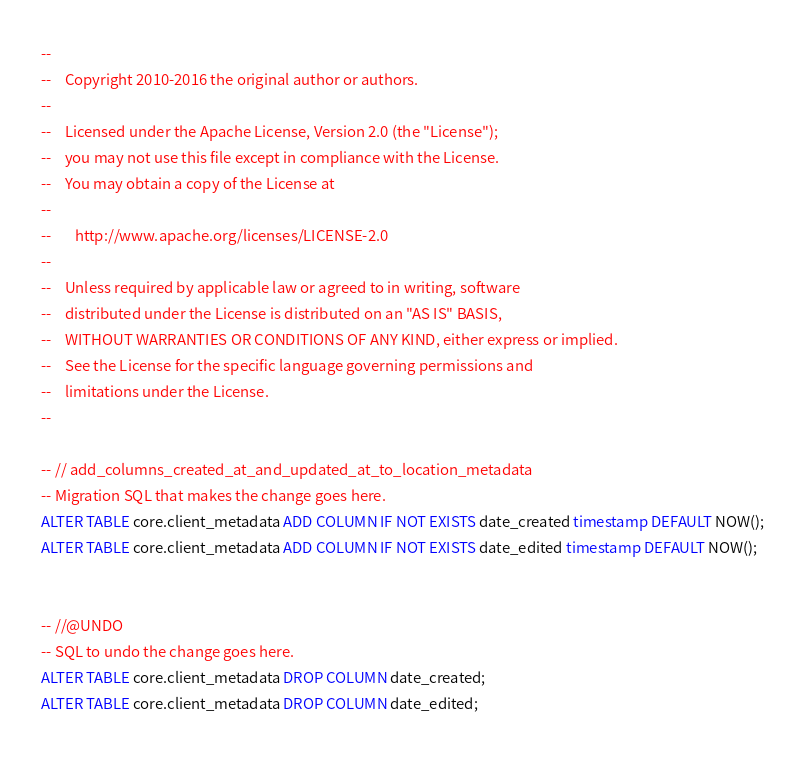Convert code to text. <code><loc_0><loc_0><loc_500><loc_500><_SQL_>--
--    Copyright 2010-2016 the original author or authors.
--
--    Licensed under the Apache License, Version 2.0 (the "License");
--    you may not use this file except in compliance with the License.
--    You may obtain a copy of the License at
--
--       http://www.apache.org/licenses/LICENSE-2.0
--
--    Unless required by applicable law or agreed to in writing, software
--    distributed under the License is distributed on an "AS IS" BASIS,
--    WITHOUT WARRANTIES OR CONDITIONS OF ANY KIND, either express or implied.
--    See the License for the specific language governing permissions and
--    limitations under the License.
--

-- // add_columns_created_at_and_updated_at_to_location_metadata
-- Migration SQL that makes the change goes here.
ALTER TABLE core.client_metadata ADD COLUMN IF NOT EXISTS date_created timestamp DEFAULT NOW();
ALTER TABLE core.client_metadata ADD COLUMN IF NOT EXISTS date_edited timestamp DEFAULT NOW();


-- //@UNDO
-- SQL to undo the change goes here.
ALTER TABLE core.client_metadata DROP COLUMN date_created;
ALTER TABLE core.client_metadata DROP COLUMN date_edited;


</code> 